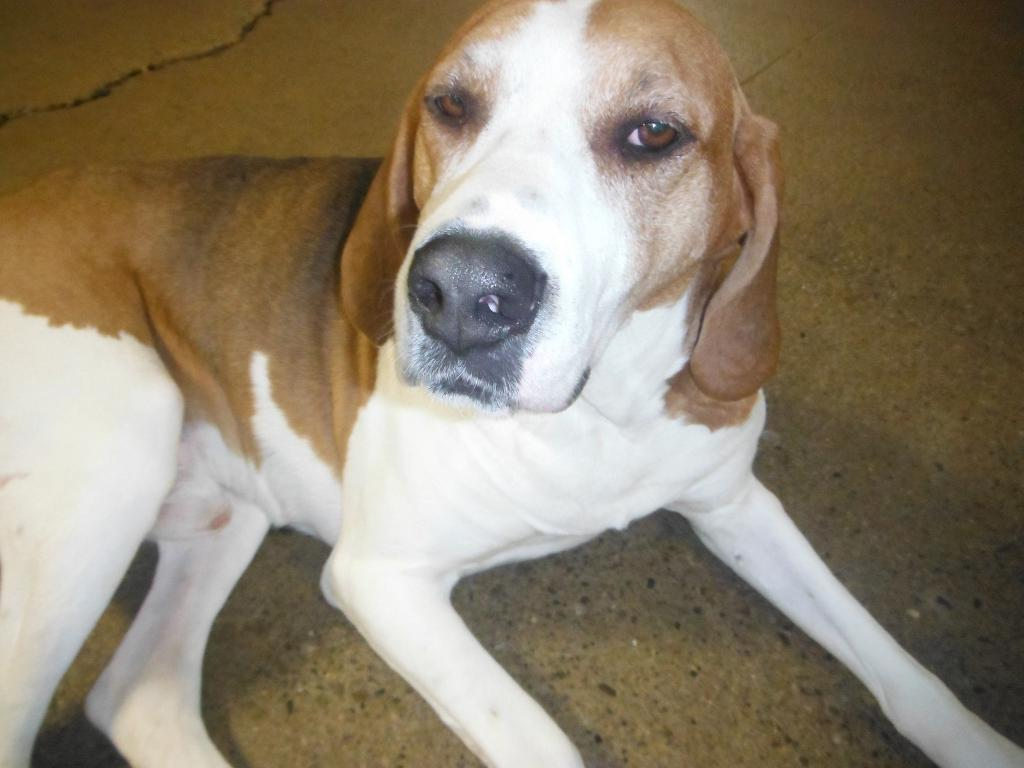What type of animal is in the picture? There is a dog in the picture. Can you describe the color of the dog? The dog is brown and white in color. Where is the dog located in the image? The dog is on the floor. What type of cake is being served to the group in the image? There is no group or cake present in the image; it features a dog on the floor. What sound does the horn make in the image? There is no horn present in the image. 